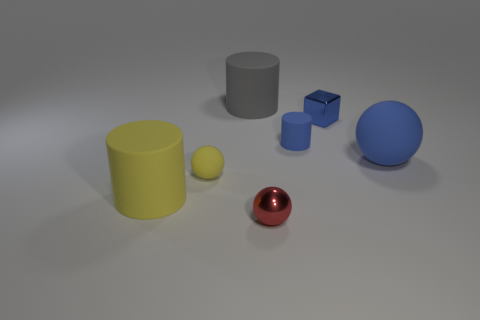Add 2 tiny cylinders. How many objects exist? 9 Subtract all cubes. How many objects are left? 6 Add 3 tiny red objects. How many tiny red objects exist? 4 Subtract 0 gray cubes. How many objects are left? 7 Subtract all small brown balls. Subtract all blue cubes. How many objects are left? 6 Add 4 small red metal objects. How many small red metal objects are left? 5 